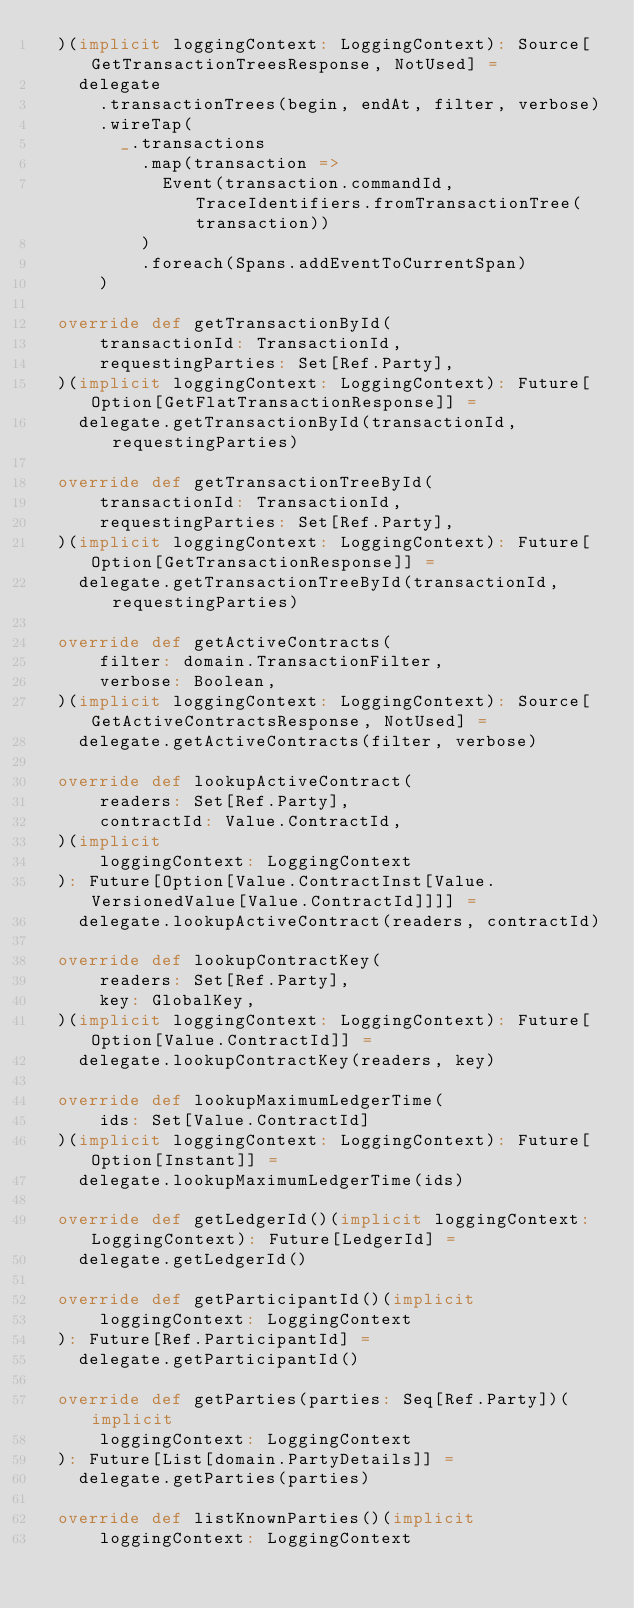<code> <loc_0><loc_0><loc_500><loc_500><_Scala_>  )(implicit loggingContext: LoggingContext): Source[GetTransactionTreesResponse, NotUsed] =
    delegate
      .transactionTrees(begin, endAt, filter, verbose)
      .wireTap(
        _.transactions
          .map(transaction =>
            Event(transaction.commandId, TraceIdentifiers.fromTransactionTree(transaction))
          )
          .foreach(Spans.addEventToCurrentSpan)
      )

  override def getTransactionById(
      transactionId: TransactionId,
      requestingParties: Set[Ref.Party],
  )(implicit loggingContext: LoggingContext): Future[Option[GetFlatTransactionResponse]] =
    delegate.getTransactionById(transactionId, requestingParties)

  override def getTransactionTreeById(
      transactionId: TransactionId,
      requestingParties: Set[Ref.Party],
  )(implicit loggingContext: LoggingContext): Future[Option[GetTransactionResponse]] =
    delegate.getTransactionTreeById(transactionId, requestingParties)

  override def getActiveContracts(
      filter: domain.TransactionFilter,
      verbose: Boolean,
  )(implicit loggingContext: LoggingContext): Source[GetActiveContractsResponse, NotUsed] =
    delegate.getActiveContracts(filter, verbose)

  override def lookupActiveContract(
      readers: Set[Ref.Party],
      contractId: Value.ContractId,
  )(implicit
      loggingContext: LoggingContext
  ): Future[Option[Value.ContractInst[Value.VersionedValue[Value.ContractId]]]] =
    delegate.lookupActiveContract(readers, contractId)

  override def lookupContractKey(
      readers: Set[Ref.Party],
      key: GlobalKey,
  )(implicit loggingContext: LoggingContext): Future[Option[Value.ContractId]] =
    delegate.lookupContractKey(readers, key)

  override def lookupMaximumLedgerTime(
      ids: Set[Value.ContractId]
  )(implicit loggingContext: LoggingContext): Future[Option[Instant]] =
    delegate.lookupMaximumLedgerTime(ids)

  override def getLedgerId()(implicit loggingContext: LoggingContext): Future[LedgerId] =
    delegate.getLedgerId()

  override def getParticipantId()(implicit
      loggingContext: LoggingContext
  ): Future[Ref.ParticipantId] =
    delegate.getParticipantId()

  override def getParties(parties: Seq[Ref.Party])(implicit
      loggingContext: LoggingContext
  ): Future[List[domain.PartyDetails]] =
    delegate.getParties(parties)

  override def listKnownParties()(implicit
      loggingContext: LoggingContext</code> 